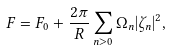Convert formula to latex. <formula><loc_0><loc_0><loc_500><loc_500>F = F _ { 0 } + \frac { 2 \pi } { R } \sum _ { n > 0 } \Omega _ { n } | \zeta _ { n } | ^ { 2 } ,</formula> 